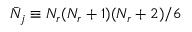Convert formula to latex. <formula><loc_0><loc_0><loc_500><loc_500>\bar { N } _ { j } \equiv N _ { r } ( N _ { r } + 1 ) ( N _ { r } + 2 ) / 6</formula> 